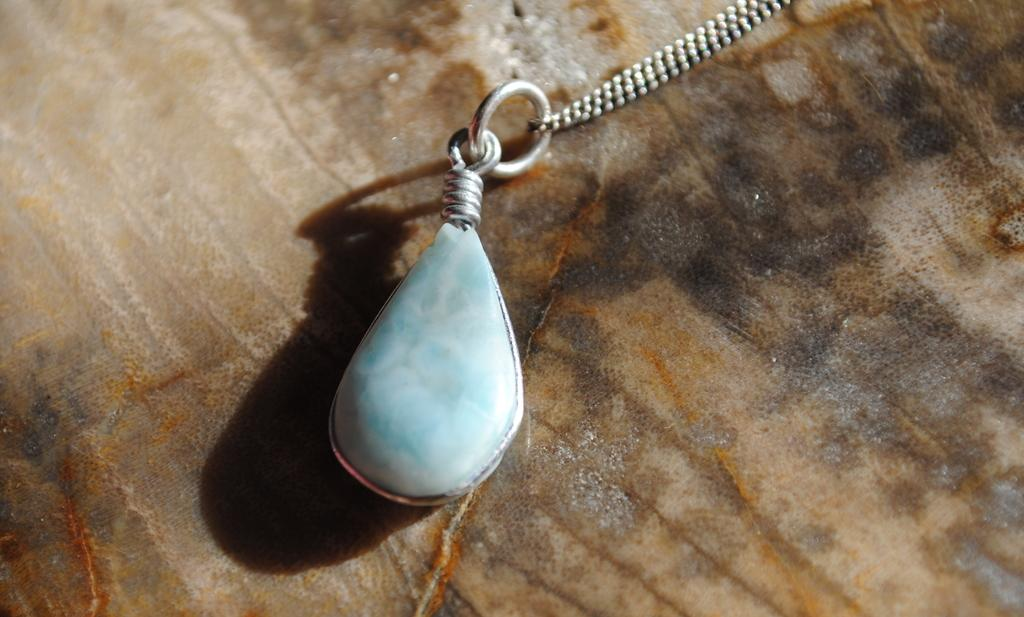What color is the object that is visible in the image? The object in the image is blue. How is the blue object connected to another object? The blue object is attached to a chain. What type of surface is the chain resting on? The chain is on a brown and black surface. What type of substance is being used to create love in the image? There is no indication of love or any substance related to it in the image. 